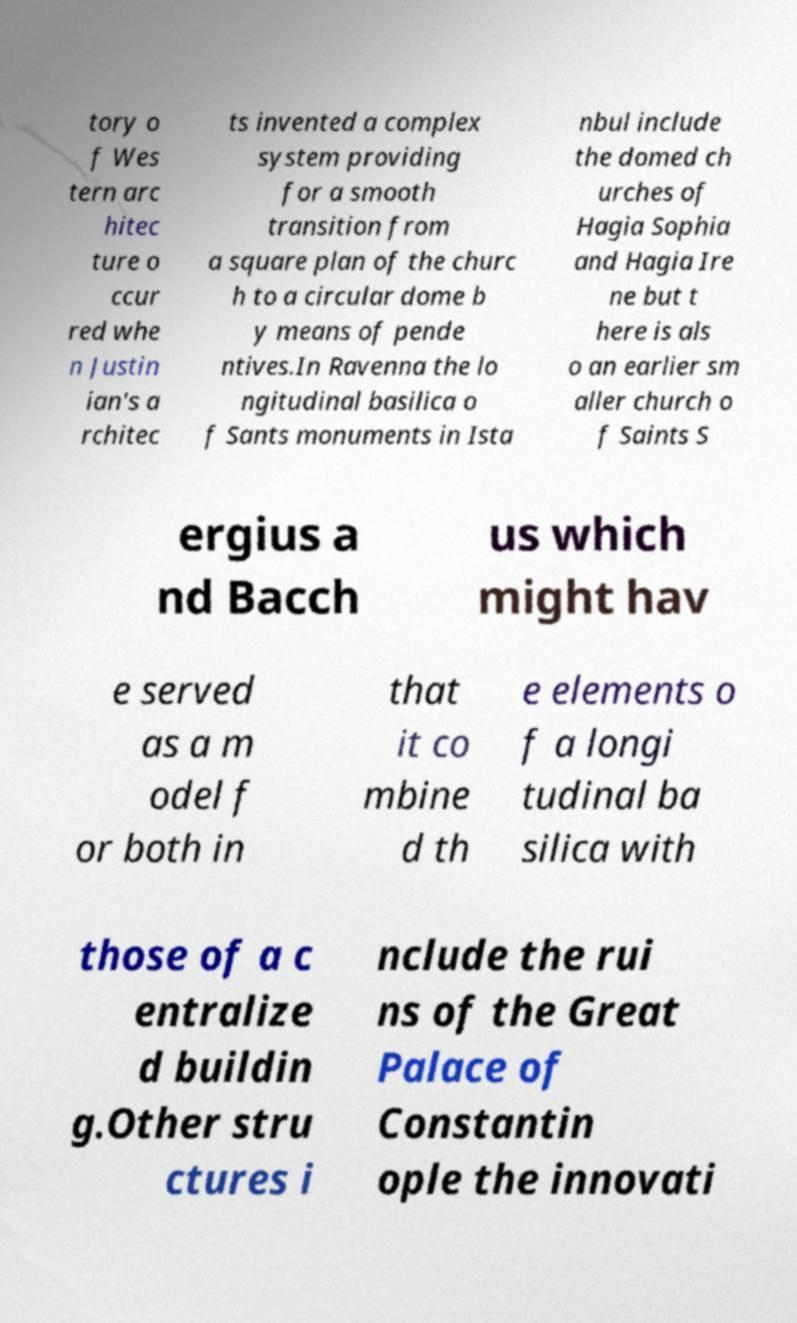I need the written content from this picture converted into text. Can you do that? tory o f Wes tern arc hitec ture o ccur red whe n Justin ian's a rchitec ts invented a complex system providing for a smooth transition from a square plan of the churc h to a circular dome b y means of pende ntives.In Ravenna the lo ngitudinal basilica o f Sants monuments in Ista nbul include the domed ch urches of Hagia Sophia and Hagia Ire ne but t here is als o an earlier sm aller church o f Saints S ergius a nd Bacch us which might hav e served as a m odel f or both in that it co mbine d th e elements o f a longi tudinal ba silica with those of a c entralize d buildin g.Other stru ctures i nclude the rui ns of the Great Palace of Constantin ople the innovati 